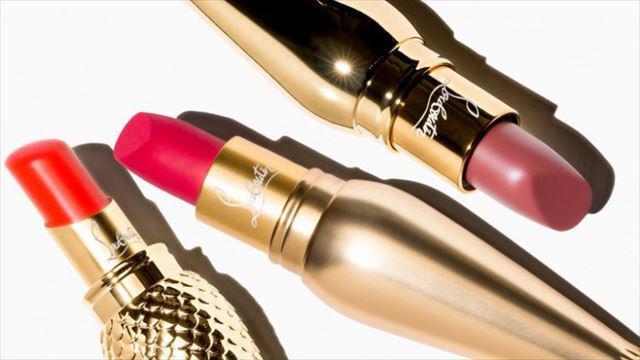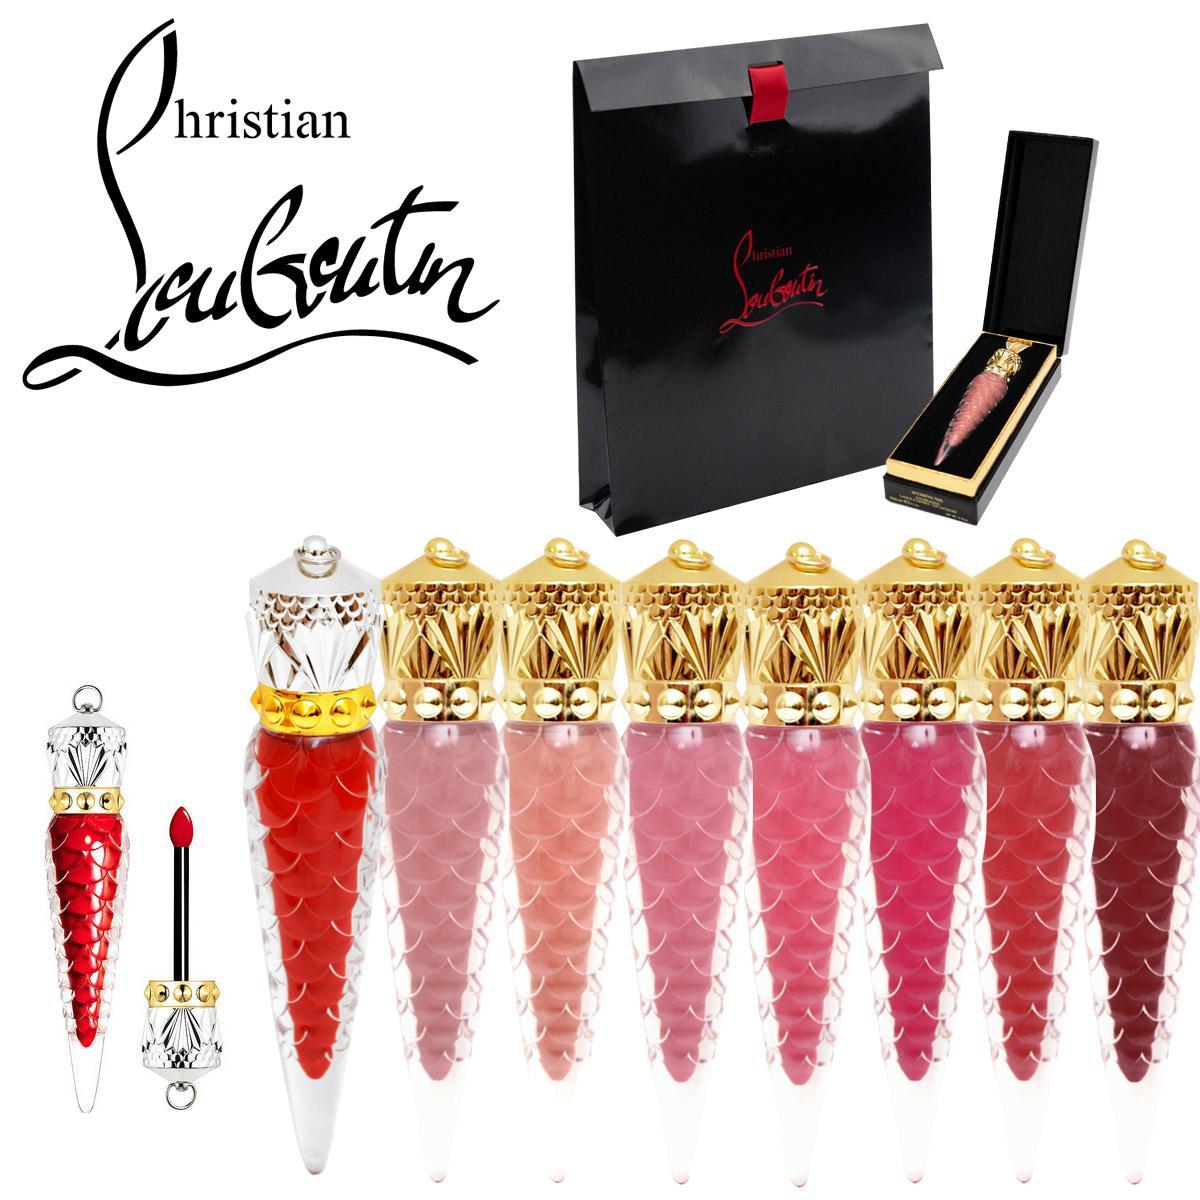The first image is the image on the left, the second image is the image on the right. Evaluate the accuracy of this statement regarding the images: "An image shows eight different makeup shades in tapered decorative containers, displayed scattered instead of in rows.". Is it true? Answer yes or no. No. 